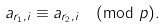Convert formula to latex. <formula><loc_0><loc_0><loc_500><loc_500>a _ { r _ { 1 } , i } \equiv a _ { r _ { 2 } , i } \pmod { p } .</formula> 